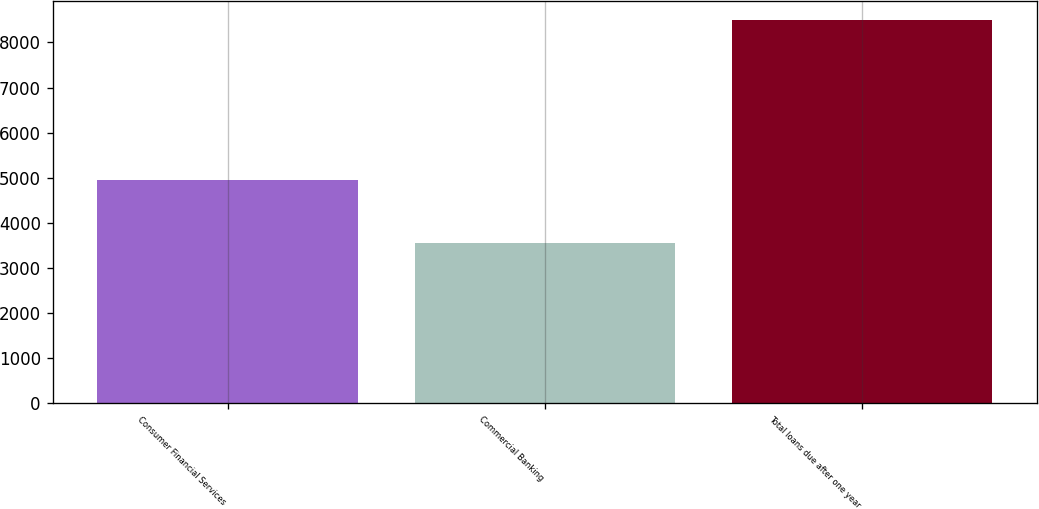<chart> <loc_0><loc_0><loc_500><loc_500><bar_chart><fcel>Consumer Financial Services<fcel>Commercial Banking<fcel>Total loans due after one year<nl><fcel>4948.8<fcel>3545.8<fcel>8494.6<nl></chart> 